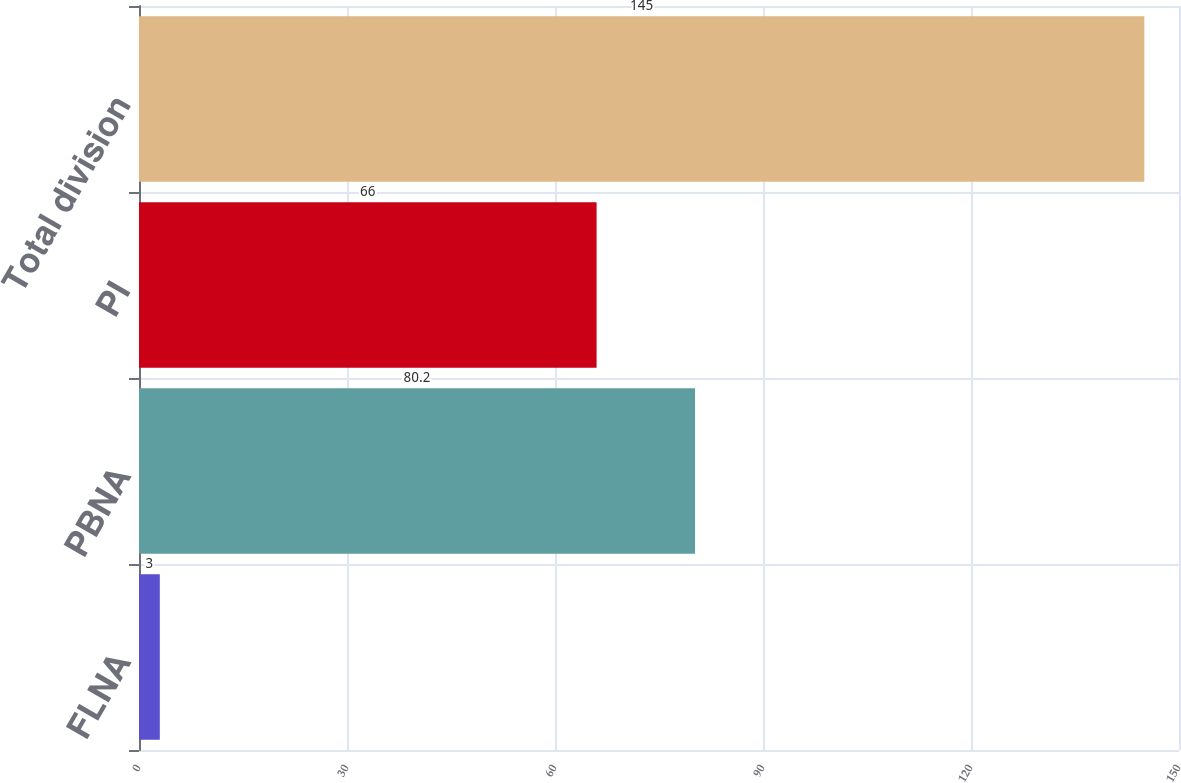Convert chart to OTSL. <chart><loc_0><loc_0><loc_500><loc_500><bar_chart><fcel>FLNA<fcel>PBNA<fcel>PI<fcel>Total division<nl><fcel>3<fcel>80.2<fcel>66<fcel>145<nl></chart> 